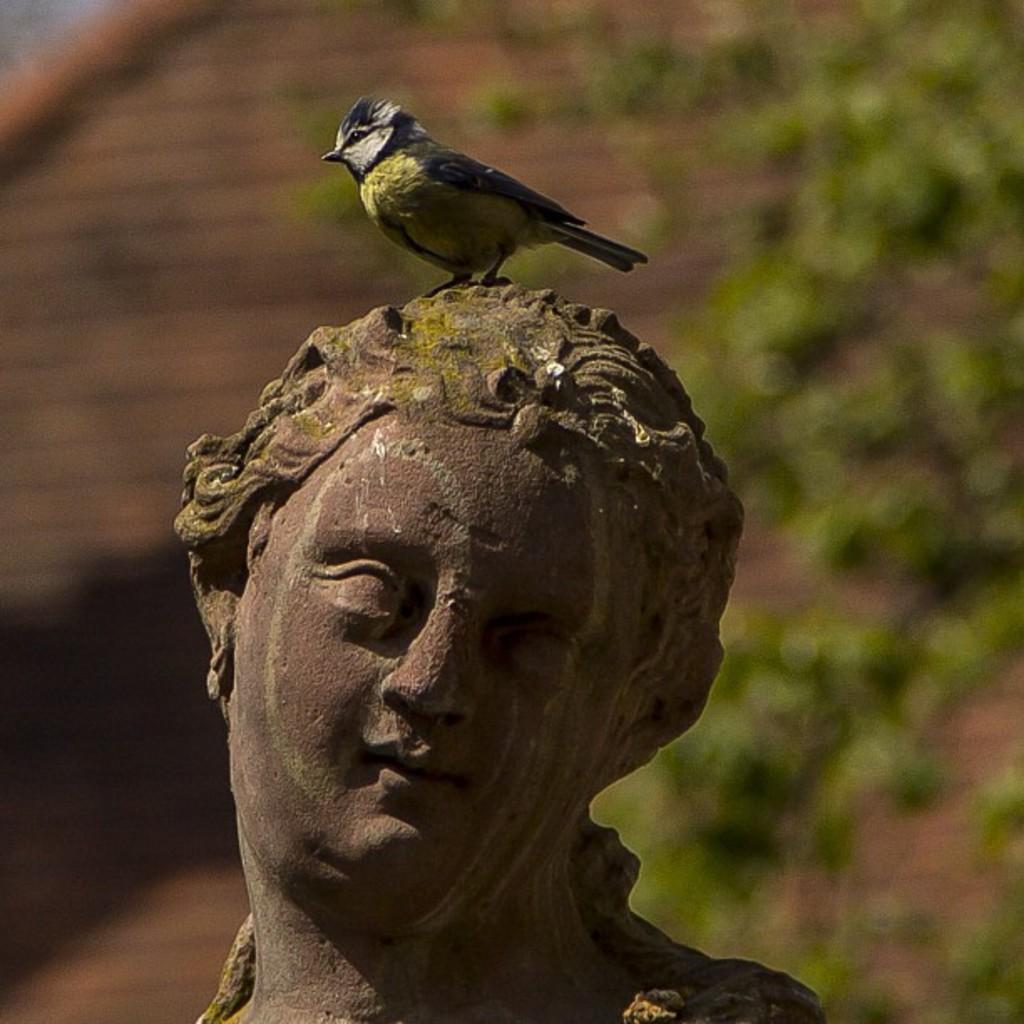Please provide a concise description of this image. In this image we can see a bird on the statue. The background of the image is not clear. 